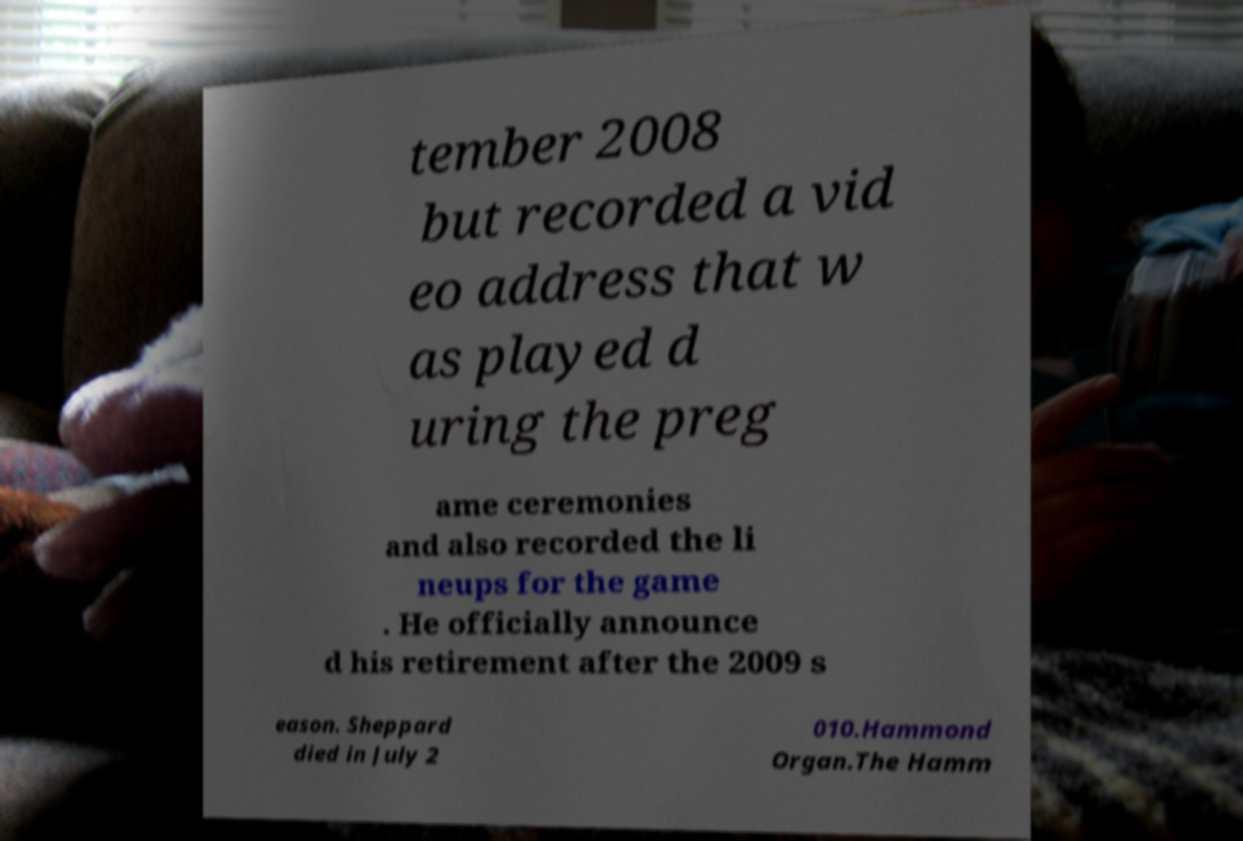Could you assist in decoding the text presented in this image and type it out clearly? tember 2008 but recorded a vid eo address that w as played d uring the preg ame ceremonies and also recorded the li neups for the game . He officially announce d his retirement after the 2009 s eason. Sheppard died in July 2 010.Hammond Organ.The Hamm 